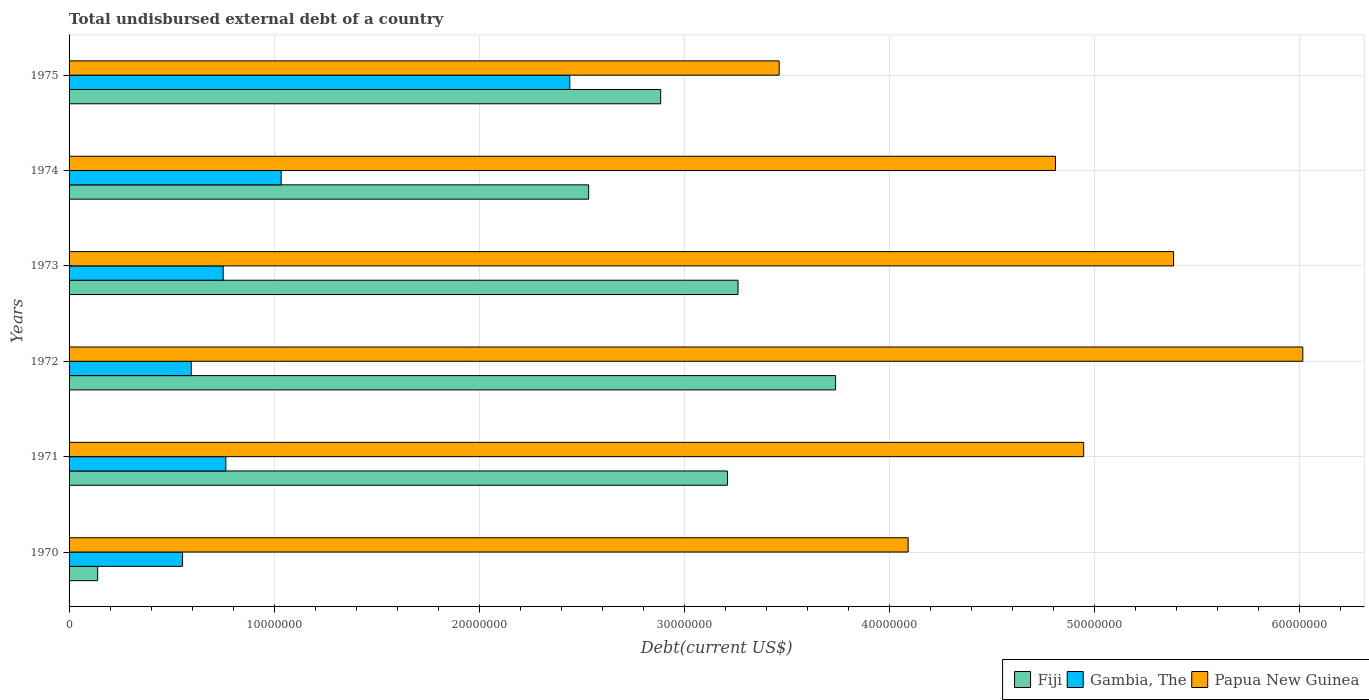Are the number of bars on each tick of the Y-axis equal?
Your response must be concise. Yes. How many bars are there on the 2nd tick from the top?
Give a very brief answer. 3. How many bars are there on the 1st tick from the bottom?
Your answer should be compact. 3. What is the label of the 2nd group of bars from the top?
Make the answer very short. 1974. What is the total undisbursed external debt in Gambia, The in 1970?
Your response must be concise. 5.54e+06. Across all years, what is the maximum total undisbursed external debt in Fiji?
Offer a terse response. 3.74e+07. Across all years, what is the minimum total undisbursed external debt in Gambia, The?
Your answer should be compact. 5.54e+06. In which year was the total undisbursed external debt in Gambia, The maximum?
Give a very brief answer. 1975. In which year was the total undisbursed external debt in Papua New Guinea minimum?
Your answer should be very brief. 1975. What is the total total undisbursed external debt in Fiji in the graph?
Your answer should be very brief. 1.58e+08. What is the difference between the total undisbursed external debt in Papua New Guinea in 1974 and that in 1975?
Offer a very short reply. 1.35e+07. What is the difference between the total undisbursed external debt in Gambia, The in 1975 and the total undisbursed external debt in Papua New Guinea in 1974?
Your answer should be compact. -2.37e+07. What is the average total undisbursed external debt in Papua New Guinea per year?
Offer a terse response. 4.79e+07. In the year 1971, what is the difference between the total undisbursed external debt in Gambia, The and total undisbursed external debt in Fiji?
Provide a short and direct response. -2.45e+07. What is the ratio of the total undisbursed external debt in Papua New Guinea in 1972 to that in 1973?
Your answer should be compact. 1.12. Is the total undisbursed external debt in Papua New Guinea in 1972 less than that in 1973?
Provide a short and direct response. No. Is the difference between the total undisbursed external debt in Gambia, The in 1970 and 1971 greater than the difference between the total undisbursed external debt in Fiji in 1970 and 1971?
Ensure brevity in your answer.  Yes. What is the difference between the highest and the second highest total undisbursed external debt in Gambia, The?
Provide a succinct answer. 1.41e+07. What is the difference between the highest and the lowest total undisbursed external debt in Papua New Guinea?
Offer a terse response. 2.55e+07. In how many years, is the total undisbursed external debt in Fiji greater than the average total undisbursed external debt in Fiji taken over all years?
Your response must be concise. 4. What does the 3rd bar from the top in 1975 represents?
Your answer should be very brief. Fiji. What does the 2nd bar from the bottom in 1972 represents?
Make the answer very short. Gambia, The. How many bars are there?
Your answer should be compact. 18. Are all the bars in the graph horizontal?
Provide a succinct answer. Yes. How many years are there in the graph?
Keep it short and to the point. 6. Are the values on the major ticks of X-axis written in scientific E-notation?
Provide a succinct answer. No. Does the graph contain grids?
Make the answer very short. Yes. How are the legend labels stacked?
Provide a short and direct response. Horizontal. What is the title of the graph?
Your answer should be compact. Total undisbursed external debt of a country. What is the label or title of the X-axis?
Your response must be concise. Debt(current US$). What is the Debt(current US$) of Fiji in 1970?
Provide a short and direct response. 1.39e+06. What is the Debt(current US$) in Gambia, The in 1970?
Provide a succinct answer. 5.54e+06. What is the Debt(current US$) in Papua New Guinea in 1970?
Offer a very short reply. 4.09e+07. What is the Debt(current US$) in Fiji in 1971?
Your response must be concise. 3.21e+07. What is the Debt(current US$) in Gambia, The in 1971?
Provide a succinct answer. 7.65e+06. What is the Debt(current US$) of Papua New Guinea in 1971?
Your answer should be compact. 4.95e+07. What is the Debt(current US$) of Fiji in 1972?
Offer a terse response. 3.74e+07. What is the Debt(current US$) of Gambia, The in 1972?
Offer a very short reply. 5.96e+06. What is the Debt(current US$) in Papua New Guinea in 1972?
Provide a short and direct response. 6.02e+07. What is the Debt(current US$) in Fiji in 1973?
Your answer should be compact. 3.26e+07. What is the Debt(current US$) of Gambia, The in 1973?
Keep it short and to the point. 7.52e+06. What is the Debt(current US$) in Papua New Guinea in 1973?
Keep it short and to the point. 5.39e+07. What is the Debt(current US$) of Fiji in 1974?
Your answer should be compact. 2.53e+07. What is the Debt(current US$) in Gambia, The in 1974?
Your answer should be very brief. 1.03e+07. What is the Debt(current US$) in Papua New Guinea in 1974?
Make the answer very short. 4.81e+07. What is the Debt(current US$) in Fiji in 1975?
Keep it short and to the point. 2.89e+07. What is the Debt(current US$) in Gambia, The in 1975?
Make the answer very short. 2.44e+07. What is the Debt(current US$) of Papua New Guinea in 1975?
Offer a very short reply. 3.46e+07. Across all years, what is the maximum Debt(current US$) of Fiji?
Provide a succinct answer. 3.74e+07. Across all years, what is the maximum Debt(current US$) of Gambia, The?
Provide a succinct answer. 2.44e+07. Across all years, what is the maximum Debt(current US$) in Papua New Guinea?
Offer a terse response. 6.02e+07. Across all years, what is the minimum Debt(current US$) of Fiji?
Your response must be concise. 1.39e+06. Across all years, what is the minimum Debt(current US$) in Gambia, The?
Offer a very short reply. 5.54e+06. Across all years, what is the minimum Debt(current US$) in Papua New Guinea?
Your answer should be very brief. 3.46e+07. What is the total Debt(current US$) of Fiji in the graph?
Make the answer very short. 1.58e+08. What is the total Debt(current US$) in Gambia, The in the graph?
Provide a succinct answer. 6.14e+07. What is the total Debt(current US$) in Papua New Guinea in the graph?
Your answer should be very brief. 2.87e+08. What is the difference between the Debt(current US$) of Fiji in 1970 and that in 1971?
Offer a very short reply. -3.07e+07. What is the difference between the Debt(current US$) of Gambia, The in 1970 and that in 1971?
Your answer should be very brief. -2.11e+06. What is the difference between the Debt(current US$) in Papua New Guinea in 1970 and that in 1971?
Make the answer very short. -8.56e+06. What is the difference between the Debt(current US$) in Fiji in 1970 and that in 1972?
Ensure brevity in your answer.  -3.60e+07. What is the difference between the Debt(current US$) in Gambia, The in 1970 and that in 1972?
Your response must be concise. -4.26e+05. What is the difference between the Debt(current US$) of Papua New Guinea in 1970 and that in 1972?
Provide a succinct answer. -1.93e+07. What is the difference between the Debt(current US$) of Fiji in 1970 and that in 1973?
Your answer should be very brief. -3.12e+07. What is the difference between the Debt(current US$) in Gambia, The in 1970 and that in 1973?
Offer a very short reply. -1.98e+06. What is the difference between the Debt(current US$) in Papua New Guinea in 1970 and that in 1973?
Make the answer very short. -1.29e+07. What is the difference between the Debt(current US$) of Fiji in 1970 and that in 1974?
Offer a very short reply. -2.40e+07. What is the difference between the Debt(current US$) of Gambia, The in 1970 and that in 1974?
Your response must be concise. -4.81e+06. What is the difference between the Debt(current US$) of Papua New Guinea in 1970 and that in 1974?
Keep it short and to the point. -7.19e+06. What is the difference between the Debt(current US$) in Fiji in 1970 and that in 1975?
Offer a very short reply. -2.75e+07. What is the difference between the Debt(current US$) in Gambia, The in 1970 and that in 1975?
Provide a short and direct response. -1.89e+07. What is the difference between the Debt(current US$) in Papua New Guinea in 1970 and that in 1975?
Your answer should be very brief. 6.29e+06. What is the difference between the Debt(current US$) in Fiji in 1971 and that in 1972?
Offer a very short reply. -5.27e+06. What is the difference between the Debt(current US$) of Gambia, The in 1971 and that in 1972?
Make the answer very short. 1.69e+06. What is the difference between the Debt(current US$) of Papua New Guinea in 1971 and that in 1972?
Offer a very short reply. -1.07e+07. What is the difference between the Debt(current US$) in Fiji in 1971 and that in 1973?
Your answer should be compact. -5.16e+05. What is the difference between the Debt(current US$) of Gambia, The in 1971 and that in 1973?
Ensure brevity in your answer.  1.30e+05. What is the difference between the Debt(current US$) in Papua New Guinea in 1971 and that in 1973?
Give a very brief answer. -4.38e+06. What is the difference between the Debt(current US$) in Fiji in 1971 and that in 1974?
Make the answer very short. 6.77e+06. What is the difference between the Debt(current US$) in Gambia, The in 1971 and that in 1974?
Provide a succinct answer. -2.70e+06. What is the difference between the Debt(current US$) in Papua New Guinea in 1971 and that in 1974?
Offer a terse response. 1.38e+06. What is the difference between the Debt(current US$) of Fiji in 1971 and that in 1975?
Ensure brevity in your answer.  3.26e+06. What is the difference between the Debt(current US$) in Gambia, The in 1971 and that in 1975?
Your response must be concise. -1.68e+07. What is the difference between the Debt(current US$) of Papua New Guinea in 1971 and that in 1975?
Provide a short and direct response. 1.49e+07. What is the difference between the Debt(current US$) in Fiji in 1972 and that in 1973?
Offer a very short reply. 4.76e+06. What is the difference between the Debt(current US$) of Gambia, The in 1972 and that in 1973?
Give a very brief answer. -1.56e+06. What is the difference between the Debt(current US$) of Papua New Guinea in 1972 and that in 1973?
Ensure brevity in your answer.  6.30e+06. What is the difference between the Debt(current US$) of Fiji in 1972 and that in 1974?
Offer a very short reply. 1.20e+07. What is the difference between the Debt(current US$) in Gambia, The in 1972 and that in 1974?
Give a very brief answer. -4.38e+06. What is the difference between the Debt(current US$) of Papua New Guinea in 1972 and that in 1974?
Your answer should be compact. 1.21e+07. What is the difference between the Debt(current US$) in Fiji in 1972 and that in 1975?
Your response must be concise. 8.53e+06. What is the difference between the Debt(current US$) in Gambia, The in 1972 and that in 1975?
Make the answer very short. -1.85e+07. What is the difference between the Debt(current US$) of Papua New Guinea in 1972 and that in 1975?
Provide a short and direct response. 2.55e+07. What is the difference between the Debt(current US$) in Fiji in 1973 and that in 1974?
Provide a short and direct response. 7.29e+06. What is the difference between the Debt(current US$) in Gambia, The in 1973 and that in 1974?
Your response must be concise. -2.83e+06. What is the difference between the Debt(current US$) of Papua New Guinea in 1973 and that in 1974?
Your answer should be very brief. 5.76e+06. What is the difference between the Debt(current US$) in Fiji in 1973 and that in 1975?
Give a very brief answer. 3.77e+06. What is the difference between the Debt(current US$) in Gambia, The in 1973 and that in 1975?
Your response must be concise. -1.69e+07. What is the difference between the Debt(current US$) in Papua New Guinea in 1973 and that in 1975?
Give a very brief answer. 1.92e+07. What is the difference between the Debt(current US$) in Fiji in 1974 and that in 1975?
Give a very brief answer. -3.51e+06. What is the difference between the Debt(current US$) of Gambia, The in 1974 and that in 1975?
Give a very brief answer. -1.41e+07. What is the difference between the Debt(current US$) in Papua New Guinea in 1974 and that in 1975?
Your response must be concise. 1.35e+07. What is the difference between the Debt(current US$) of Fiji in 1970 and the Debt(current US$) of Gambia, The in 1971?
Your response must be concise. -6.25e+06. What is the difference between the Debt(current US$) in Fiji in 1970 and the Debt(current US$) in Papua New Guinea in 1971?
Your answer should be compact. -4.81e+07. What is the difference between the Debt(current US$) of Gambia, The in 1970 and the Debt(current US$) of Papua New Guinea in 1971?
Your response must be concise. -4.40e+07. What is the difference between the Debt(current US$) of Fiji in 1970 and the Debt(current US$) of Gambia, The in 1972?
Your answer should be compact. -4.57e+06. What is the difference between the Debt(current US$) in Fiji in 1970 and the Debt(current US$) in Papua New Guinea in 1972?
Ensure brevity in your answer.  -5.88e+07. What is the difference between the Debt(current US$) in Gambia, The in 1970 and the Debt(current US$) in Papua New Guinea in 1972?
Your answer should be compact. -5.46e+07. What is the difference between the Debt(current US$) in Fiji in 1970 and the Debt(current US$) in Gambia, The in 1973?
Provide a short and direct response. -6.12e+06. What is the difference between the Debt(current US$) in Fiji in 1970 and the Debt(current US$) in Papua New Guinea in 1973?
Provide a short and direct response. -5.25e+07. What is the difference between the Debt(current US$) of Gambia, The in 1970 and the Debt(current US$) of Papua New Guinea in 1973?
Provide a succinct answer. -4.83e+07. What is the difference between the Debt(current US$) of Fiji in 1970 and the Debt(current US$) of Gambia, The in 1974?
Your answer should be compact. -8.95e+06. What is the difference between the Debt(current US$) of Fiji in 1970 and the Debt(current US$) of Papua New Guinea in 1974?
Make the answer very short. -4.67e+07. What is the difference between the Debt(current US$) of Gambia, The in 1970 and the Debt(current US$) of Papua New Guinea in 1974?
Give a very brief answer. -4.26e+07. What is the difference between the Debt(current US$) in Fiji in 1970 and the Debt(current US$) in Gambia, The in 1975?
Provide a succinct answer. -2.30e+07. What is the difference between the Debt(current US$) in Fiji in 1970 and the Debt(current US$) in Papua New Guinea in 1975?
Offer a terse response. -3.32e+07. What is the difference between the Debt(current US$) in Gambia, The in 1970 and the Debt(current US$) in Papua New Guinea in 1975?
Offer a terse response. -2.91e+07. What is the difference between the Debt(current US$) in Fiji in 1971 and the Debt(current US$) in Gambia, The in 1972?
Provide a short and direct response. 2.62e+07. What is the difference between the Debt(current US$) of Fiji in 1971 and the Debt(current US$) of Papua New Guinea in 1972?
Your answer should be very brief. -2.81e+07. What is the difference between the Debt(current US$) of Gambia, The in 1971 and the Debt(current US$) of Papua New Guinea in 1972?
Offer a very short reply. -5.25e+07. What is the difference between the Debt(current US$) of Fiji in 1971 and the Debt(current US$) of Gambia, The in 1973?
Ensure brevity in your answer.  2.46e+07. What is the difference between the Debt(current US$) in Fiji in 1971 and the Debt(current US$) in Papua New Guinea in 1973?
Offer a very short reply. -2.18e+07. What is the difference between the Debt(current US$) in Gambia, The in 1971 and the Debt(current US$) in Papua New Guinea in 1973?
Provide a succinct answer. -4.62e+07. What is the difference between the Debt(current US$) in Fiji in 1971 and the Debt(current US$) in Gambia, The in 1974?
Your answer should be compact. 2.18e+07. What is the difference between the Debt(current US$) in Fiji in 1971 and the Debt(current US$) in Papua New Guinea in 1974?
Offer a very short reply. -1.60e+07. What is the difference between the Debt(current US$) in Gambia, The in 1971 and the Debt(current US$) in Papua New Guinea in 1974?
Provide a succinct answer. -4.05e+07. What is the difference between the Debt(current US$) in Fiji in 1971 and the Debt(current US$) in Gambia, The in 1975?
Provide a succinct answer. 7.69e+06. What is the difference between the Debt(current US$) in Fiji in 1971 and the Debt(current US$) in Papua New Guinea in 1975?
Offer a very short reply. -2.52e+06. What is the difference between the Debt(current US$) in Gambia, The in 1971 and the Debt(current US$) in Papua New Guinea in 1975?
Keep it short and to the point. -2.70e+07. What is the difference between the Debt(current US$) of Fiji in 1972 and the Debt(current US$) of Gambia, The in 1973?
Your response must be concise. 2.99e+07. What is the difference between the Debt(current US$) in Fiji in 1972 and the Debt(current US$) in Papua New Guinea in 1973?
Make the answer very short. -1.65e+07. What is the difference between the Debt(current US$) in Gambia, The in 1972 and the Debt(current US$) in Papua New Guinea in 1973?
Your answer should be very brief. -4.79e+07. What is the difference between the Debt(current US$) in Fiji in 1972 and the Debt(current US$) in Gambia, The in 1974?
Your response must be concise. 2.70e+07. What is the difference between the Debt(current US$) in Fiji in 1972 and the Debt(current US$) in Papua New Guinea in 1974?
Give a very brief answer. -1.07e+07. What is the difference between the Debt(current US$) in Gambia, The in 1972 and the Debt(current US$) in Papua New Guinea in 1974?
Your answer should be very brief. -4.22e+07. What is the difference between the Debt(current US$) of Fiji in 1972 and the Debt(current US$) of Gambia, The in 1975?
Offer a terse response. 1.30e+07. What is the difference between the Debt(current US$) in Fiji in 1972 and the Debt(current US$) in Papua New Guinea in 1975?
Provide a succinct answer. 2.75e+06. What is the difference between the Debt(current US$) in Gambia, The in 1972 and the Debt(current US$) in Papua New Guinea in 1975?
Your answer should be compact. -2.87e+07. What is the difference between the Debt(current US$) in Fiji in 1973 and the Debt(current US$) in Gambia, The in 1974?
Your response must be concise. 2.23e+07. What is the difference between the Debt(current US$) in Fiji in 1973 and the Debt(current US$) in Papua New Guinea in 1974?
Offer a very short reply. -1.55e+07. What is the difference between the Debt(current US$) in Gambia, The in 1973 and the Debt(current US$) in Papua New Guinea in 1974?
Give a very brief answer. -4.06e+07. What is the difference between the Debt(current US$) in Fiji in 1973 and the Debt(current US$) in Gambia, The in 1975?
Give a very brief answer. 8.21e+06. What is the difference between the Debt(current US$) of Fiji in 1973 and the Debt(current US$) of Papua New Guinea in 1975?
Provide a short and direct response. -2.01e+06. What is the difference between the Debt(current US$) in Gambia, The in 1973 and the Debt(current US$) in Papua New Guinea in 1975?
Your response must be concise. -2.71e+07. What is the difference between the Debt(current US$) of Fiji in 1974 and the Debt(current US$) of Gambia, The in 1975?
Provide a short and direct response. 9.20e+05. What is the difference between the Debt(current US$) of Fiji in 1974 and the Debt(current US$) of Papua New Guinea in 1975?
Your response must be concise. -9.29e+06. What is the difference between the Debt(current US$) in Gambia, The in 1974 and the Debt(current US$) in Papua New Guinea in 1975?
Give a very brief answer. -2.43e+07. What is the average Debt(current US$) of Fiji per year?
Keep it short and to the point. 2.63e+07. What is the average Debt(current US$) in Gambia, The per year?
Give a very brief answer. 1.02e+07. What is the average Debt(current US$) in Papua New Guinea per year?
Provide a succinct answer. 4.79e+07. In the year 1970, what is the difference between the Debt(current US$) of Fiji and Debt(current US$) of Gambia, The?
Offer a very short reply. -4.14e+06. In the year 1970, what is the difference between the Debt(current US$) of Fiji and Debt(current US$) of Papua New Guinea?
Give a very brief answer. -3.95e+07. In the year 1970, what is the difference between the Debt(current US$) in Gambia, The and Debt(current US$) in Papua New Guinea?
Provide a succinct answer. -3.54e+07. In the year 1971, what is the difference between the Debt(current US$) in Fiji and Debt(current US$) in Gambia, The?
Give a very brief answer. 2.45e+07. In the year 1971, what is the difference between the Debt(current US$) in Fiji and Debt(current US$) in Papua New Guinea?
Give a very brief answer. -1.74e+07. In the year 1971, what is the difference between the Debt(current US$) in Gambia, The and Debt(current US$) in Papua New Guinea?
Offer a terse response. -4.18e+07. In the year 1972, what is the difference between the Debt(current US$) in Fiji and Debt(current US$) in Gambia, The?
Provide a short and direct response. 3.14e+07. In the year 1972, what is the difference between the Debt(current US$) of Fiji and Debt(current US$) of Papua New Guinea?
Give a very brief answer. -2.28e+07. In the year 1972, what is the difference between the Debt(current US$) in Gambia, The and Debt(current US$) in Papua New Guinea?
Your response must be concise. -5.42e+07. In the year 1973, what is the difference between the Debt(current US$) in Fiji and Debt(current US$) in Gambia, The?
Offer a terse response. 2.51e+07. In the year 1973, what is the difference between the Debt(current US$) in Fiji and Debt(current US$) in Papua New Guinea?
Keep it short and to the point. -2.12e+07. In the year 1973, what is the difference between the Debt(current US$) of Gambia, The and Debt(current US$) of Papua New Guinea?
Give a very brief answer. -4.64e+07. In the year 1974, what is the difference between the Debt(current US$) in Fiji and Debt(current US$) in Gambia, The?
Offer a very short reply. 1.50e+07. In the year 1974, what is the difference between the Debt(current US$) in Fiji and Debt(current US$) in Papua New Guinea?
Provide a short and direct response. -2.28e+07. In the year 1974, what is the difference between the Debt(current US$) of Gambia, The and Debt(current US$) of Papua New Guinea?
Provide a succinct answer. -3.78e+07. In the year 1975, what is the difference between the Debt(current US$) of Fiji and Debt(current US$) of Gambia, The?
Your answer should be very brief. 4.43e+06. In the year 1975, what is the difference between the Debt(current US$) of Fiji and Debt(current US$) of Papua New Guinea?
Offer a very short reply. -5.78e+06. In the year 1975, what is the difference between the Debt(current US$) in Gambia, The and Debt(current US$) in Papua New Guinea?
Your answer should be compact. -1.02e+07. What is the ratio of the Debt(current US$) of Fiji in 1970 to that in 1971?
Offer a terse response. 0.04. What is the ratio of the Debt(current US$) in Gambia, The in 1970 to that in 1971?
Offer a terse response. 0.72. What is the ratio of the Debt(current US$) in Papua New Guinea in 1970 to that in 1971?
Make the answer very short. 0.83. What is the ratio of the Debt(current US$) of Fiji in 1970 to that in 1972?
Provide a succinct answer. 0.04. What is the ratio of the Debt(current US$) of Gambia, The in 1970 to that in 1972?
Ensure brevity in your answer.  0.93. What is the ratio of the Debt(current US$) of Papua New Guinea in 1970 to that in 1972?
Give a very brief answer. 0.68. What is the ratio of the Debt(current US$) of Fiji in 1970 to that in 1973?
Ensure brevity in your answer.  0.04. What is the ratio of the Debt(current US$) of Gambia, The in 1970 to that in 1973?
Offer a very short reply. 0.74. What is the ratio of the Debt(current US$) in Papua New Guinea in 1970 to that in 1973?
Ensure brevity in your answer.  0.76. What is the ratio of the Debt(current US$) in Fiji in 1970 to that in 1974?
Make the answer very short. 0.06. What is the ratio of the Debt(current US$) of Gambia, The in 1970 to that in 1974?
Your answer should be very brief. 0.54. What is the ratio of the Debt(current US$) in Papua New Guinea in 1970 to that in 1974?
Give a very brief answer. 0.85. What is the ratio of the Debt(current US$) in Fiji in 1970 to that in 1975?
Provide a short and direct response. 0.05. What is the ratio of the Debt(current US$) in Gambia, The in 1970 to that in 1975?
Your response must be concise. 0.23. What is the ratio of the Debt(current US$) in Papua New Guinea in 1970 to that in 1975?
Offer a terse response. 1.18. What is the ratio of the Debt(current US$) in Fiji in 1971 to that in 1972?
Your response must be concise. 0.86. What is the ratio of the Debt(current US$) of Gambia, The in 1971 to that in 1972?
Provide a succinct answer. 1.28. What is the ratio of the Debt(current US$) of Papua New Guinea in 1971 to that in 1972?
Make the answer very short. 0.82. What is the ratio of the Debt(current US$) of Fiji in 1971 to that in 1973?
Make the answer very short. 0.98. What is the ratio of the Debt(current US$) in Gambia, The in 1971 to that in 1973?
Provide a short and direct response. 1.02. What is the ratio of the Debt(current US$) in Papua New Guinea in 1971 to that in 1973?
Offer a terse response. 0.92. What is the ratio of the Debt(current US$) in Fiji in 1971 to that in 1974?
Your answer should be very brief. 1.27. What is the ratio of the Debt(current US$) in Gambia, The in 1971 to that in 1974?
Offer a very short reply. 0.74. What is the ratio of the Debt(current US$) of Papua New Guinea in 1971 to that in 1974?
Make the answer very short. 1.03. What is the ratio of the Debt(current US$) in Fiji in 1971 to that in 1975?
Keep it short and to the point. 1.11. What is the ratio of the Debt(current US$) of Gambia, The in 1971 to that in 1975?
Offer a very short reply. 0.31. What is the ratio of the Debt(current US$) of Papua New Guinea in 1971 to that in 1975?
Ensure brevity in your answer.  1.43. What is the ratio of the Debt(current US$) in Fiji in 1972 to that in 1973?
Your answer should be compact. 1.15. What is the ratio of the Debt(current US$) of Gambia, The in 1972 to that in 1973?
Provide a succinct answer. 0.79. What is the ratio of the Debt(current US$) of Papua New Guinea in 1972 to that in 1973?
Offer a very short reply. 1.12. What is the ratio of the Debt(current US$) of Fiji in 1972 to that in 1974?
Ensure brevity in your answer.  1.48. What is the ratio of the Debt(current US$) of Gambia, The in 1972 to that in 1974?
Your answer should be compact. 0.58. What is the ratio of the Debt(current US$) in Papua New Guinea in 1972 to that in 1974?
Your response must be concise. 1.25. What is the ratio of the Debt(current US$) in Fiji in 1972 to that in 1975?
Your response must be concise. 1.3. What is the ratio of the Debt(current US$) in Gambia, The in 1972 to that in 1975?
Ensure brevity in your answer.  0.24. What is the ratio of the Debt(current US$) of Papua New Guinea in 1972 to that in 1975?
Ensure brevity in your answer.  1.74. What is the ratio of the Debt(current US$) in Fiji in 1973 to that in 1974?
Ensure brevity in your answer.  1.29. What is the ratio of the Debt(current US$) in Gambia, The in 1973 to that in 1974?
Your answer should be compact. 0.73. What is the ratio of the Debt(current US$) in Papua New Guinea in 1973 to that in 1974?
Provide a short and direct response. 1.12. What is the ratio of the Debt(current US$) in Fiji in 1973 to that in 1975?
Give a very brief answer. 1.13. What is the ratio of the Debt(current US$) of Gambia, The in 1973 to that in 1975?
Make the answer very short. 0.31. What is the ratio of the Debt(current US$) in Papua New Guinea in 1973 to that in 1975?
Give a very brief answer. 1.56. What is the ratio of the Debt(current US$) in Fiji in 1974 to that in 1975?
Your answer should be compact. 0.88. What is the ratio of the Debt(current US$) in Gambia, The in 1974 to that in 1975?
Give a very brief answer. 0.42. What is the ratio of the Debt(current US$) in Papua New Guinea in 1974 to that in 1975?
Offer a very short reply. 1.39. What is the difference between the highest and the second highest Debt(current US$) in Fiji?
Ensure brevity in your answer.  4.76e+06. What is the difference between the highest and the second highest Debt(current US$) of Gambia, The?
Your answer should be very brief. 1.41e+07. What is the difference between the highest and the second highest Debt(current US$) of Papua New Guinea?
Provide a short and direct response. 6.30e+06. What is the difference between the highest and the lowest Debt(current US$) in Fiji?
Provide a short and direct response. 3.60e+07. What is the difference between the highest and the lowest Debt(current US$) in Gambia, The?
Make the answer very short. 1.89e+07. What is the difference between the highest and the lowest Debt(current US$) of Papua New Guinea?
Your answer should be compact. 2.55e+07. 